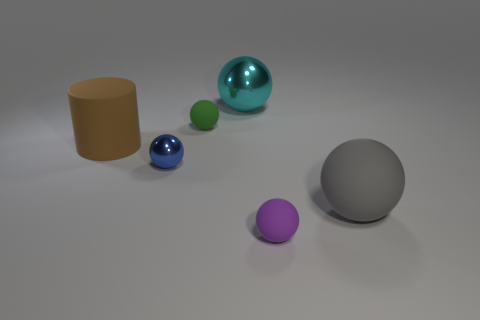There is a large object that is behind the green sphere; is it the same shape as the large brown rubber thing?
Provide a short and direct response. No. The big sphere that is made of the same material as the blue thing is what color?
Your answer should be very brief. Cyan. How many big cyan spheres have the same material as the big brown object?
Offer a terse response. 0. The small ball in front of the rubber sphere that is on the right side of the tiny matte ball in front of the green thing is what color?
Offer a terse response. Purple. Is the green rubber object the same size as the purple matte thing?
Provide a succinct answer. Yes. Is there any other thing that is the same shape as the green rubber object?
Your response must be concise. Yes. What number of objects are either tiny balls that are to the left of the purple sphere or red shiny spheres?
Give a very brief answer. 2. Is the shape of the tiny green matte thing the same as the small blue thing?
Your answer should be very brief. Yes. How many other objects are the same size as the purple rubber object?
Offer a very short reply. 2. What color is the big cylinder?
Make the answer very short. Brown. 